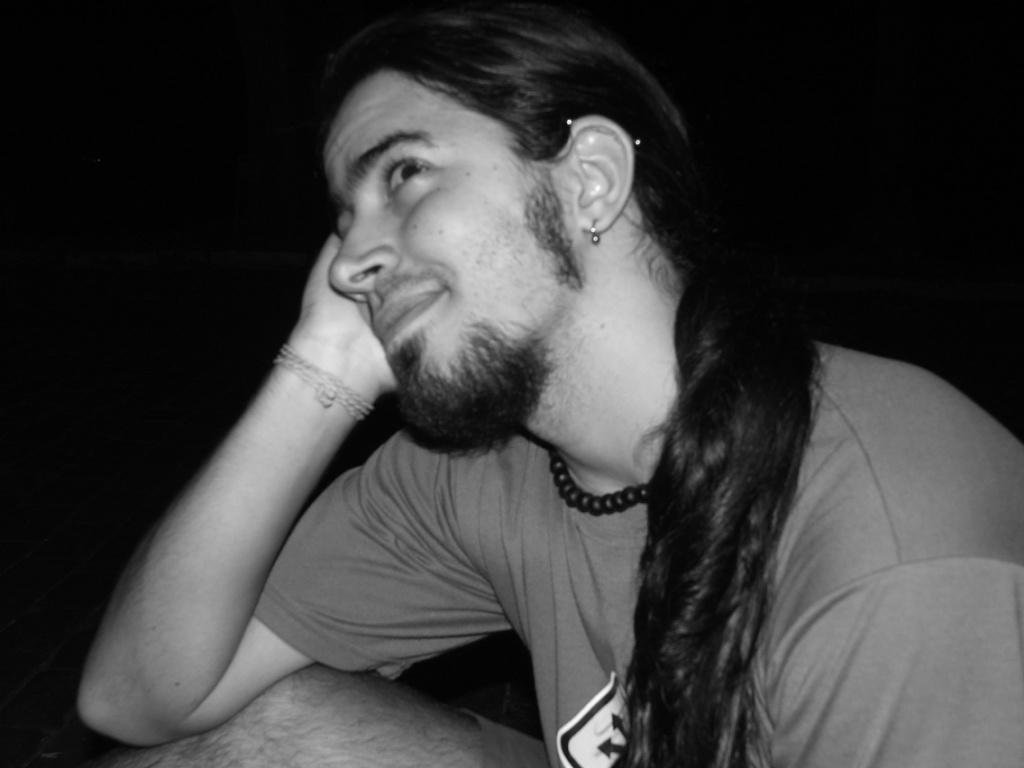What is the man in the image doing? The man is sitting in the image. What type of clothing is the man wearing? The man is wearing a T-shirt. What can be observed about the background of the image? The background of the image is dark. What type of sugar is being used to make popcorn in the image? There is no sugar or popcorn present in the image. Can you tell me how deep the lake is in the image? There is no lake present in the image. 